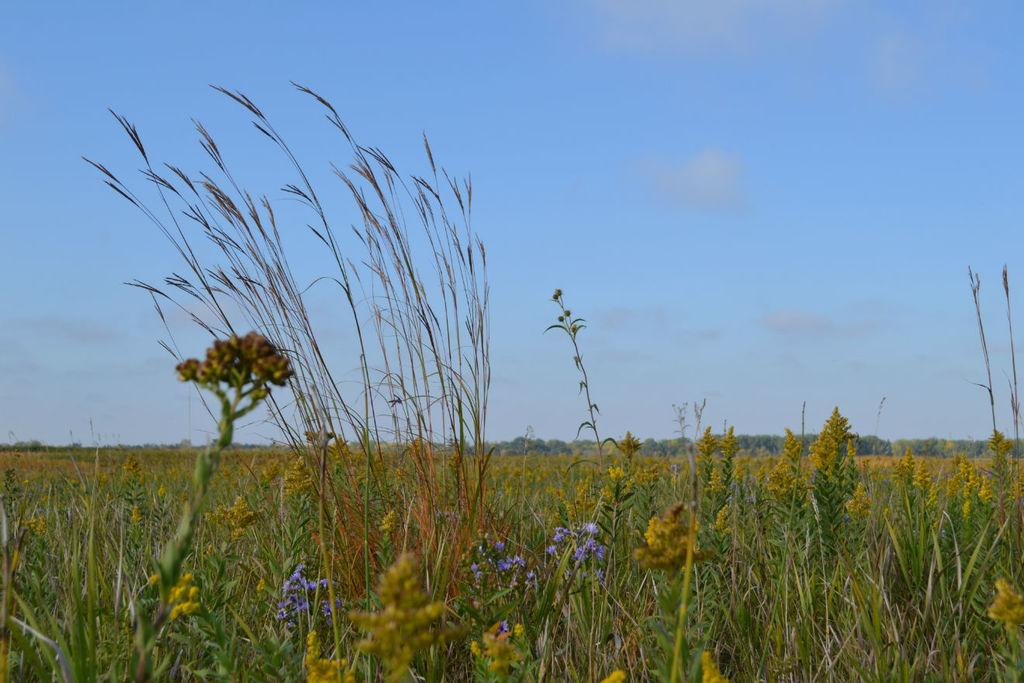What type of living organisms can be seen in the image? Plants can be seen in the image. What specific parts of the plants are visible in the image? There are buds and flowers in the image. What color are the flowers in the image? The flowers are purple in color. What can be seen in the background of the image? The sky is visible in the background of the image. Is there a dog playing with a partner in the image? There is no dog or partner present in the image; it features plants with buds and flowers. 